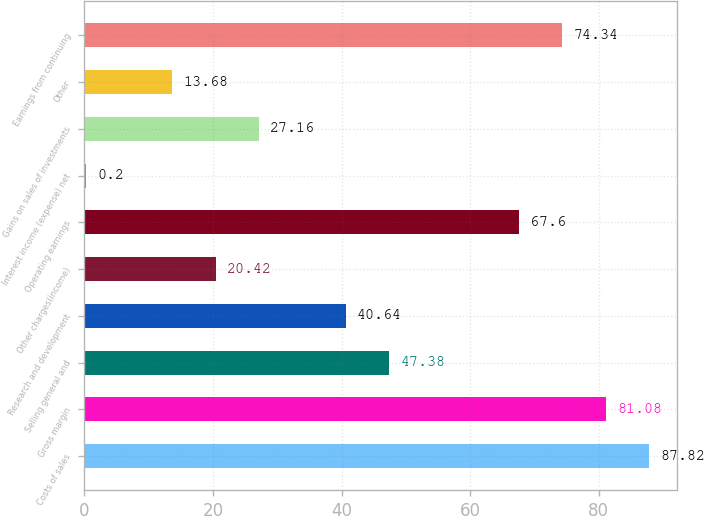Convert chart to OTSL. <chart><loc_0><loc_0><loc_500><loc_500><bar_chart><fcel>Costs of sales<fcel>Gross margin<fcel>Selling general and<fcel>Research and development<fcel>Other charges(income)<fcel>Operating earnings<fcel>Interest income (expense) net<fcel>Gains on sales of investments<fcel>Other<fcel>Earnings from continuing<nl><fcel>87.82<fcel>81.08<fcel>47.38<fcel>40.64<fcel>20.42<fcel>67.6<fcel>0.2<fcel>27.16<fcel>13.68<fcel>74.34<nl></chart> 